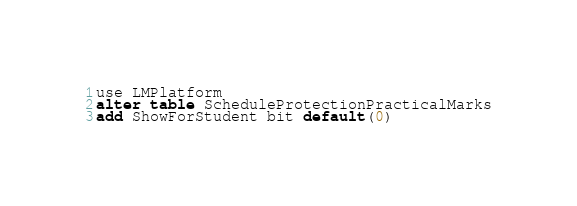Convert code to text. <code><loc_0><loc_0><loc_500><loc_500><_SQL_>use LMPlatform
alter table ScheduleProtectionPracticalMarks
add ShowForStudent bit default(0)</code> 